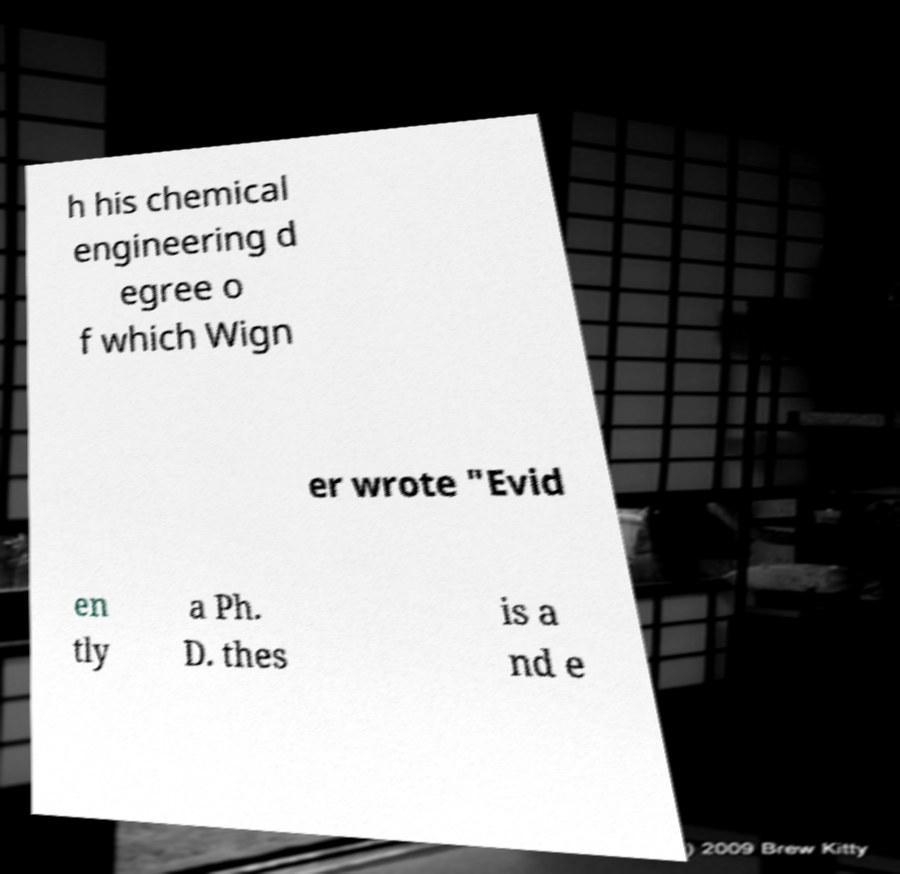Please read and relay the text visible in this image. What does it say? h his chemical engineering d egree o f which Wign er wrote "Evid en tly a Ph. D. thes is a nd e 